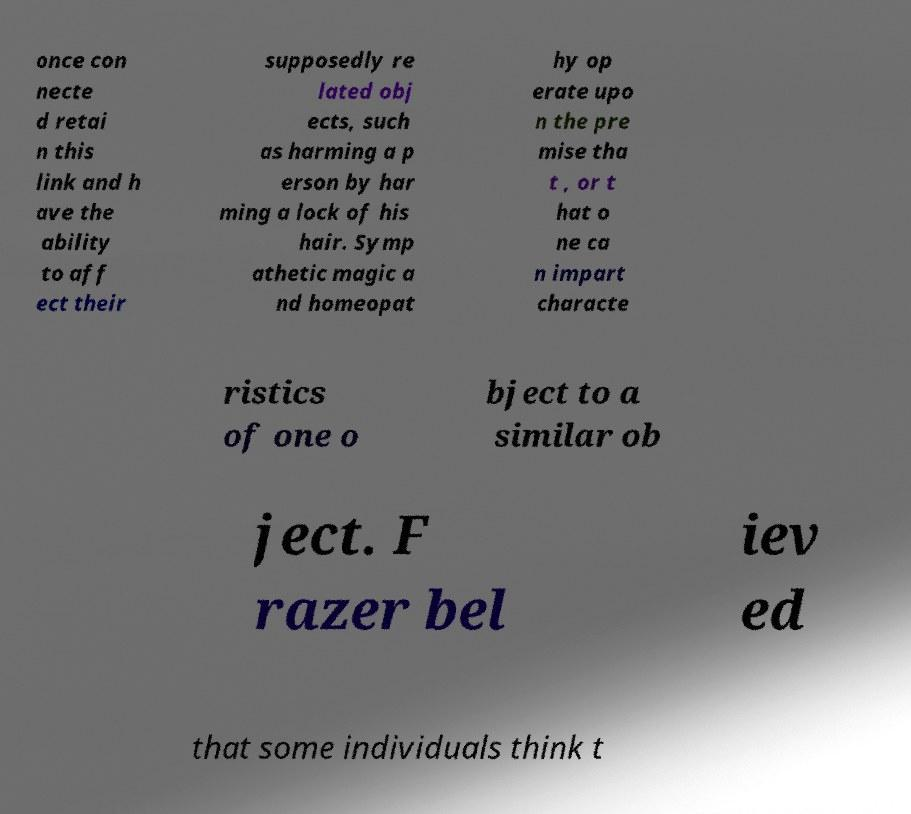There's text embedded in this image that I need extracted. Can you transcribe it verbatim? once con necte d retai n this link and h ave the ability to aff ect their supposedly re lated obj ects, such as harming a p erson by har ming a lock of his hair. Symp athetic magic a nd homeopat hy op erate upo n the pre mise tha t , or t hat o ne ca n impart characte ristics of one o bject to a similar ob ject. F razer bel iev ed that some individuals think t 